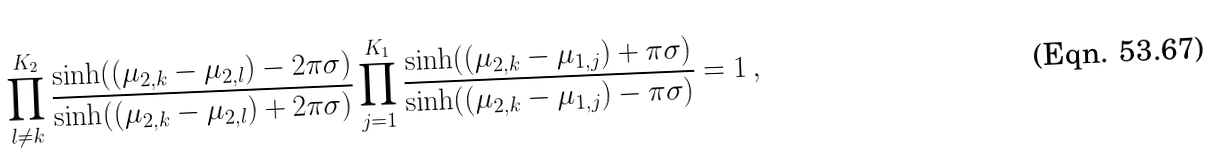<formula> <loc_0><loc_0><loc_500><loc_500>\prod _ { l \neq k } ^ { K _ { 2 } } \frac { \sinh ( ( \mu _ { 2 , k } - \mu _ { 2 , l } ) - 2 \pi \sigma ) } { \sinh ( ( \mu _ { 2 , k } - \mu _ { 2 , l } ) + 2 \pi \sigma ) } \prod _ { j = 1 } ^ { K _ { 1 } } \frac { \sinh ( ( \mu _ { 2 , k } - \mu _ { 1 , j } ) + \pi \sigma ) } { \sinh ( ( \mu _ { 2 , k } - \mu _ { 1 , j } ) - \pi \sigma ) } = 1 \, ,</formula> 